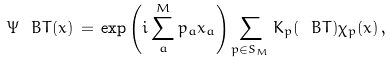Convert formula to latex. <formula><loc_0><loc_0><loc_500><loc_500>\Psi _ { \ } B T ( x ) \, = \, \exp \left ( i \sum _ { a } ^ { M } p _ { a } x _ { a } \right ) \sum _ { p \in S _ { M } } K _ { p } ( \ B T ) \chi _ { p } ( x ) \, ,</formula> 